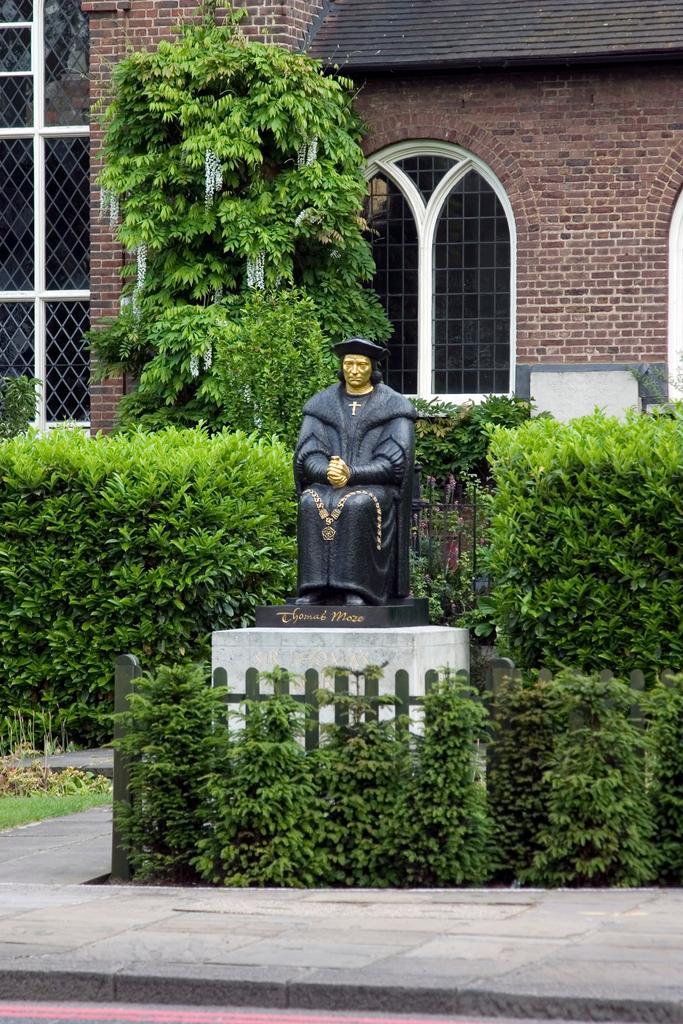Describe this image in one or two sentences. In the image there is a statue of a man, around the statue there are plants and trees, in the background there is a building. 